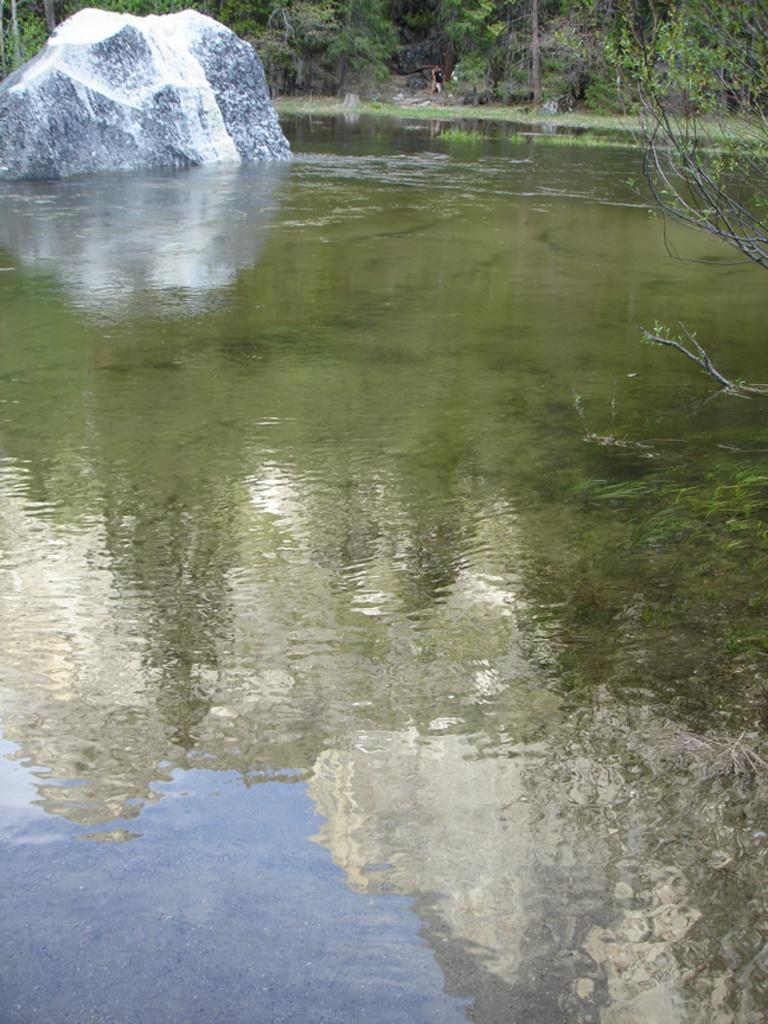What type of vegetation is present in the image? There are trees in the image. What geological feature can be seen in the image? There is a rock in the image. What natural element is visible in the image? There is water visible in the image. What type of pie is being served at the picnic in the image? There is no picnic or pie present in the image; it features trees, a rock, and water. Can you tell me what advice your dad gave you in the image? There is no reference to a dad or any advice in the image. 